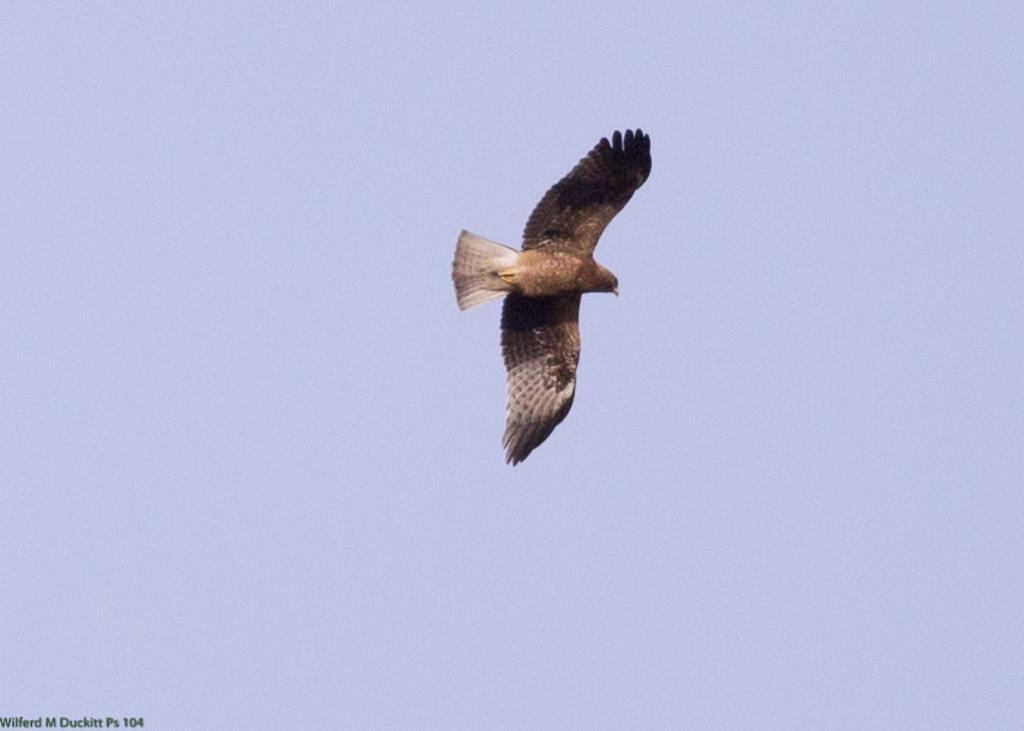Please provide a concise description of this image. There is a bird flying in the air. In the left bottom corner, there is a watermark. In the background, there is blue sky. 